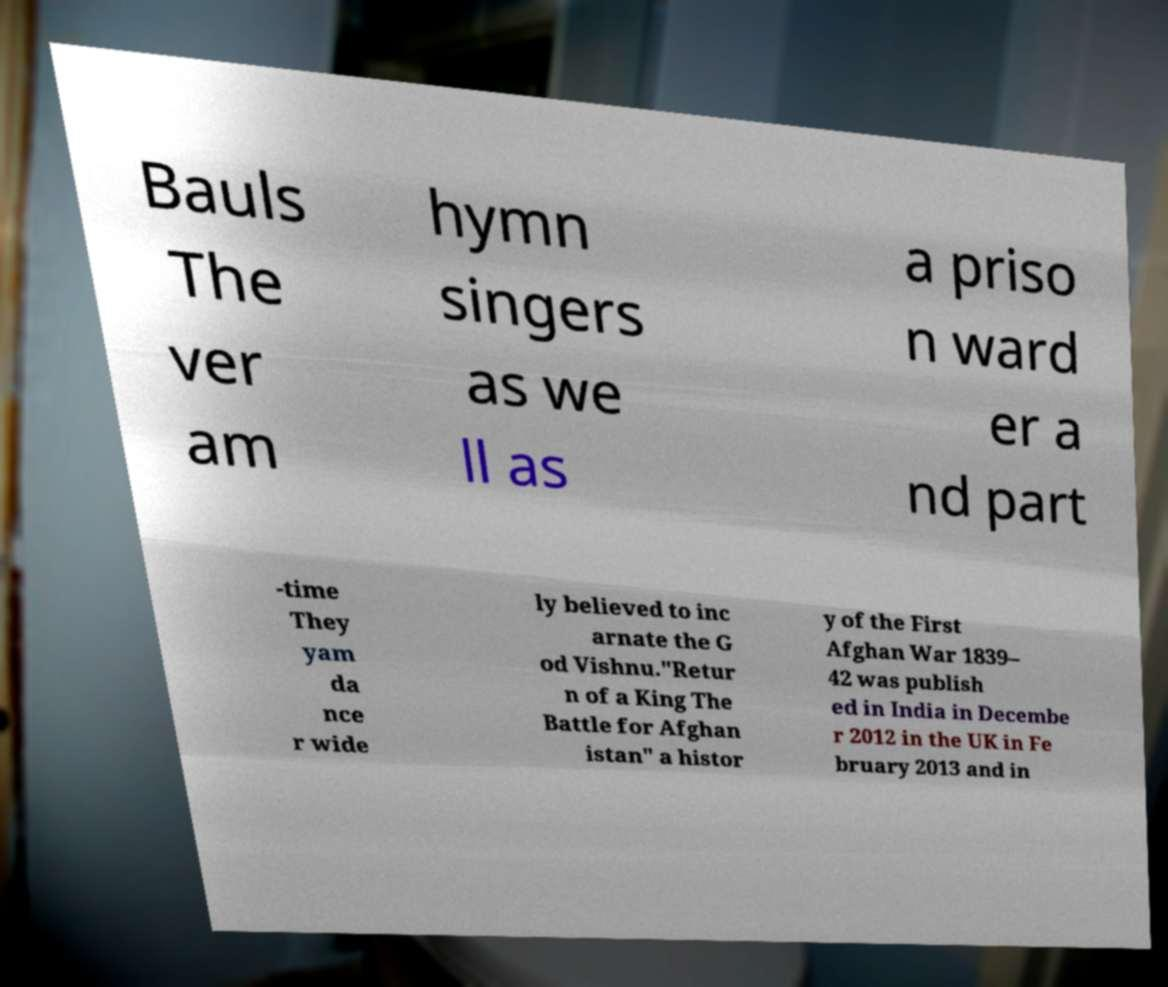Could you assist in decoding the text presented in this image and type it out clearly? Bauls The ver am hymn singers as we ll as a priso n ward er a nd part -time They yam da nce r wide ly believed to inc arnate the G od Vishnu."Retur n of a King The Battle for Afghan istan" a histor y of the First Afghan War 1839– 42 was publish ed in India in Decembe r 2012 in the UK in Fe bruary 2013 and in 